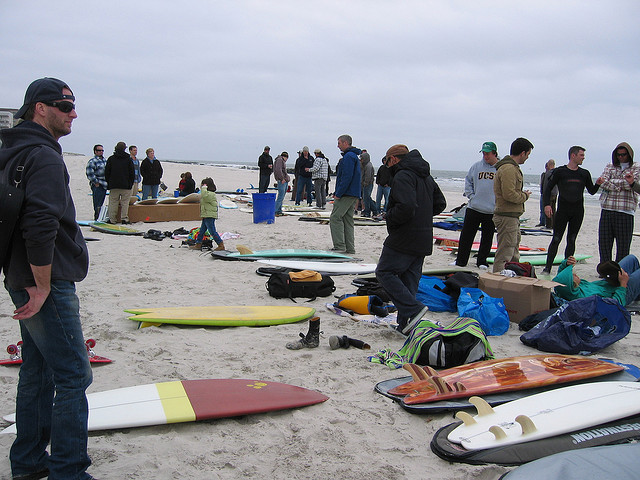Identify the text displayed in this image. UCS 